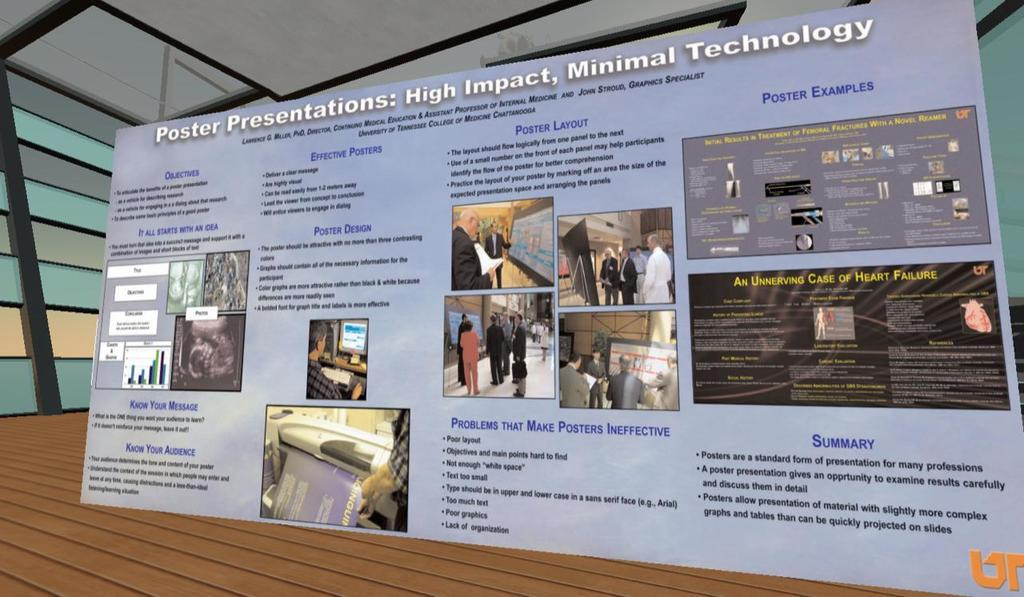<image>
Share a concise interpretation of the image provided. A poster presentation titled High Impact, Minimal Technology. 